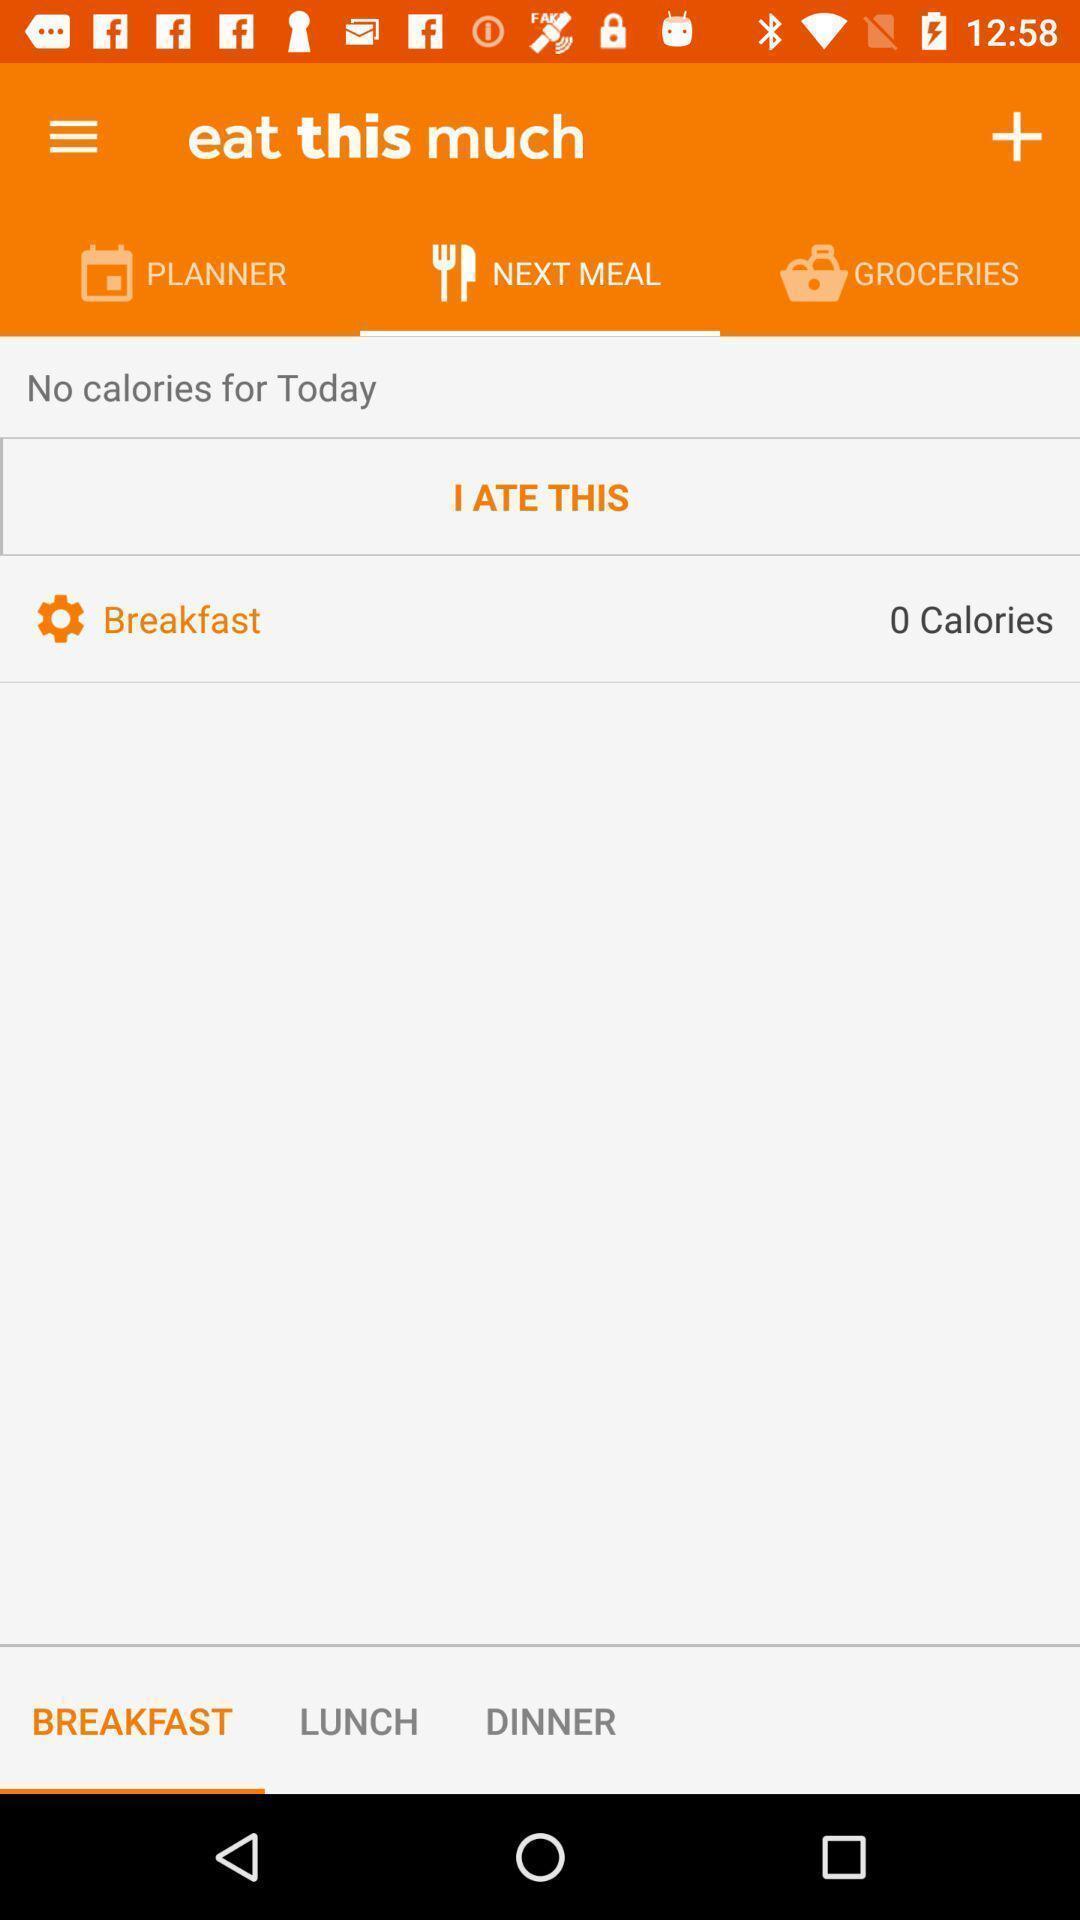Summarize the information in this screenshot. Screen shows meal options in a food app. 